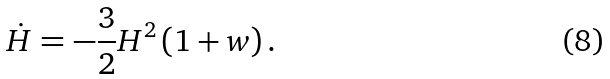Convert formula to latex. <formula><loc_0><loc_0><loc_500><loc_500>\dot { H } = - \frac { 3 } { 2 } H ^ { 2 } \left ( 1 + w \right ) .</formula> 